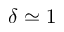<formula> <loc_0><loc_0><loc_500><loc_500>\delta \simeq 1</formula> 